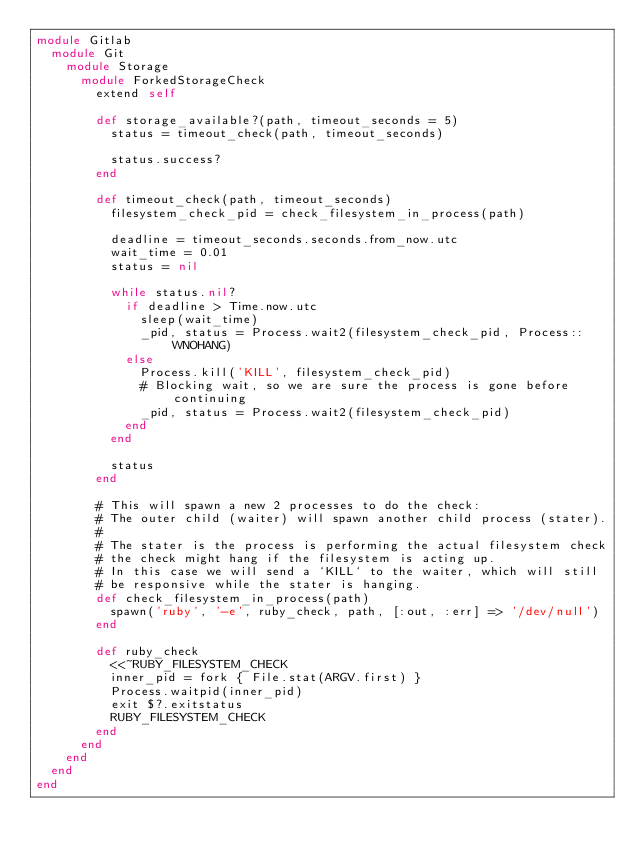<code> <loc_0><loc_0><loc_500><loc_500><_Ruby_>module Gitlab
  module Git
    module Storage
      module ForkedStorageCheck
        extend self

        def storage_available?(path, timeout_seconds = 5)
          status = timeout_check(path, timeout_seconds)

          status.success?
        end

        def timeout_check(path, timeout_seconds)
          filesystem_check_pid = check_filesystem_in_process(path)

          deadline = timeout_seconds.seconds.from_now.utc
          wait_time = 0.01
          status = nil

          while status.nil?
            if deadline > Time.now.utc
              sleep(wait_time)
              _pid, status = Process.wait2(filesystem_check_pid, Process::WNOHANG)
            else
              Process.kill('KILL', filesystem_check_pid)
              # Blocking wait, so we are sure the process is gone before continuing
              _pid, status = Process.wait2(filesystem_check_pid)
            end
          end

          status
        end

        # This will spawn a new 2 processes to do the check:
        # The outer child (waiter) will spawn another child process (stater).
        #
        # The stater is the process is performing the actual filesystem check
        # the check might hang if the filesystem is acting up.
        # In this case we will send a `KILL` to the waiter, which will still
        # be responsive while the stater is hanging.
        def check_filesystem_in_process(path)
          spawn('ruby', '-e', ruby_check, path, [:out, :err] => '/dev/null')
        end

        def ruby_check
          <<~RUBY_FILESYSTEM_CHECK
          inner_pid = fork { File.stat(ARGV.first) }
          Process.waitpid(inner_pid)
          exit $?.exitstatus
          RUBY_FILESYSTEM_CHECK
        end
      end
    end
  end
end
</code> 